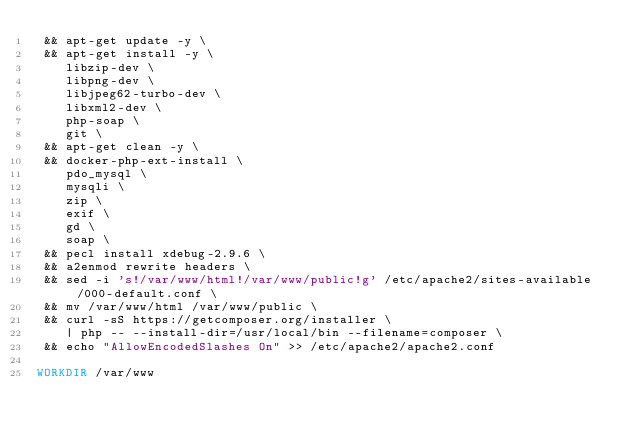<code> <loc_0><loc_0><loc_500><loc_500><_Dockerfile_> && apt-get update -y \
 && apt-get install -y \
    libzip-dev \
    libpng-dev \
    libjpeg62-turbo-dev \
    libxml2-dev \
    php-soap \
    git \
 && apt-get clean -y \
 && docker-php-ext-install \
    pdo_mysql \
    mysqli \
    zip \
    exif \
    gd \
    soap \
 && pecl install xdebug-2.9.6 \
 && a2enmod rewrite headers \
 && sed -i 's!/var/www/html!/var/www/public!g' /etc/apache2/sites-available/000-default.conf \
 && mv /var/www/html /var/www/public \
 && curl -sS https://getcomposer.org/installer \
    | php -- --install-dir=/usr/local/bin --filename=composer \
 && echo "AllowEncodedSlashes On" >> /etc/apache2/apache2.conf

WORKDIR /var/www</code> 